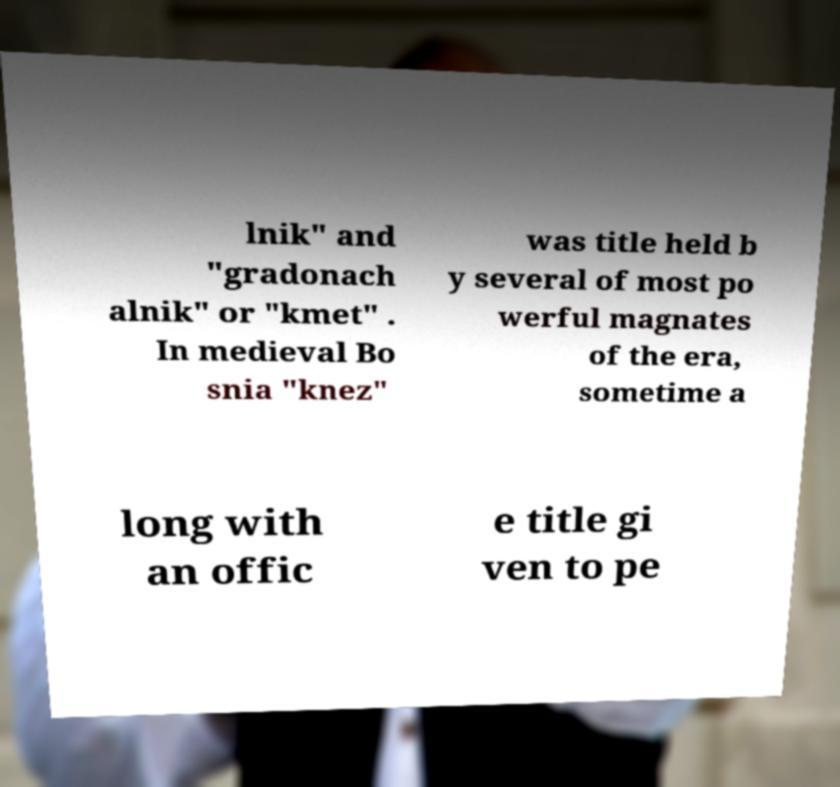For documentation purposes, I need the text within this image transcribed. Could you provide that? lnik" and "gradonach alnik" or "kmet" . In medieval Bo snia "knez" was title held b y several of most po werful magnates of the era, sometime a long with an offic e title gi ven to pe 